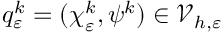Convert formula to latex. <formula><loc_0><loc_0><loc_500><loc_500>q _ { \varepsilon } ^ { k } = ( \chi _ { \varepsilon } ^ { k } , \psi ^ { k } ) \in \mathcal { V } _ { h , \varepsilon }</formula> 